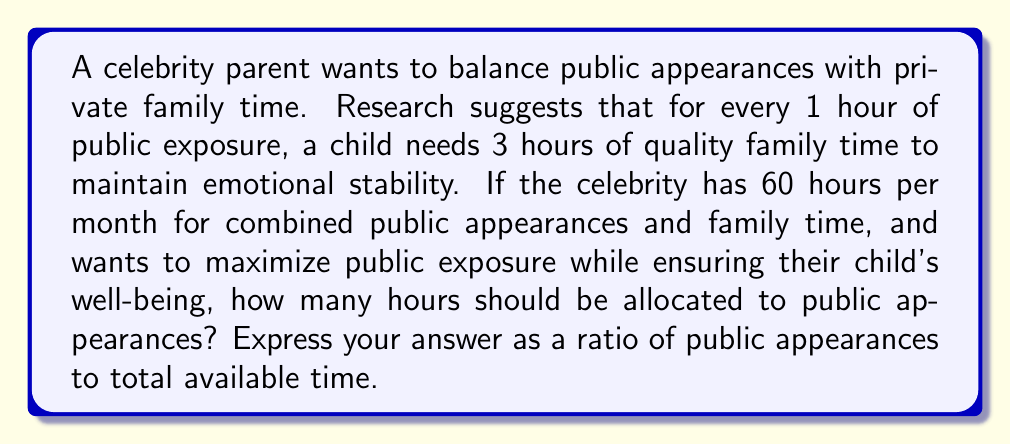Solve this math problem. Let's approach this step-by-step:

1) Let $x$ be the number of hours spent on public appearances.

2) For every hour of public appearance, 3 hours of family time are needed. So, family time = $3x$.

3) The total time available is 60 hours. This can be expressed as:
   
   $x + 3x = 60$

4) Simplify the equation:
   
   $4x = 60$

5) Solve for $x$:
   
   $x = 60 \div 4 = 15$

6) So, 15 hours should be allocated to public appearances.

7) To express this as a ratio of public appearances to total available time:
   
   $\frac{\text{Public appearance time}}{\text{Total time}} = \frac{15}{60} = \frac{1}{4}$
Answer: $1:4$ 